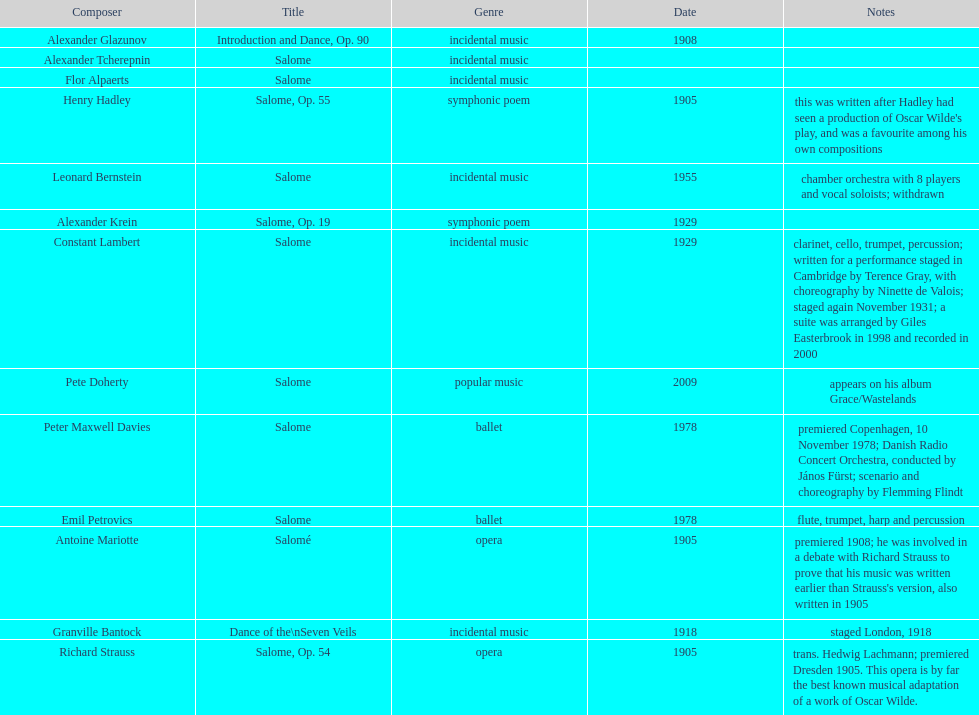Which composer is listed below pete doherty? Alexander Glazunov. 